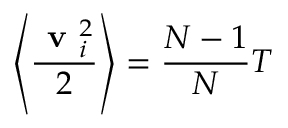Convert formula to latex. <formula><loc_0><loc_0><loc_500><loc_500>\left \langle \frac { v _ { i } ^ { 2 } } { 2 } \right \rangle = \frac { N - 1 } { N } T</formula> 